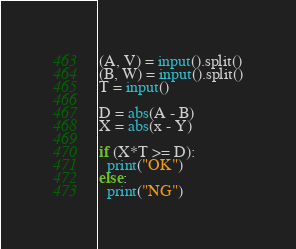Convert code to text. <code><loc_0><loc_0><loc_500><loc_500><_Python_>(A, V) = input().split()
(B, W) = input().split()
T = input()

D = abs(A - B)
X = abs(x - Y)

if (X*T >= D):
  print("OK")
else:
  print("NG")
</code> 